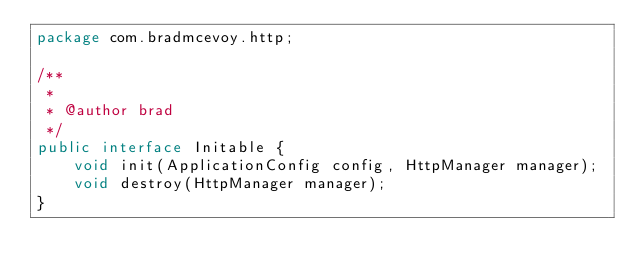Convert code to text. <code><loc_0><loc_0><loc_500><loc_500><_Java_>package com.bradmcevoy.http;

/**
 *
 * @author brad
 */
public interface Initable {
    void init(ApplicationConfig config, HttpManager manager);
    void destroy(HttpManager manager);
}
</code> 